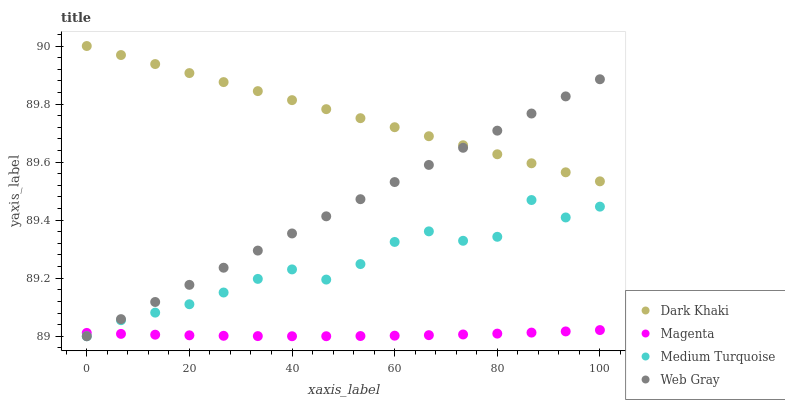Does Magenta have the minimum area under the curve?
Answer yes or no. Yes. Does Dark Khaki have the maximum area under the curve?
Answer yes or no. Yes. Does Web Gray have the minimum area under the curve?
Answer yes or no. No. Does Web Gray have the maximum area under the curve?
Answer yes or no. No. Is Web Gray the smoothest?
Answer yes or no. Yes. Is Medium Turquoise the roughest?
Answer yes or no. Yes. Is Magenta the smoothest?
Answer yes or no. No. Is Magenta the roughest?
Answer yes or no. No. Does Web Gray have the lowest value?
Answer yes or no. Yes. Does Magenta have the lowest value?
Answer yes or no. No. Does Dark Khaki have the highest value?
Answer yes or no. Yes. Does Web Gray have the highest value?
Answer yes or no. No. Is Medium Turquoise less than Dark Khaki?
Answer yes or no. Yes. Is Dark Khaki greater than Medium Turquoise?
Answer yes or no. Yes. Does Medium Turquoise intersect Magenta?
Answer yes or no. Yes. Is Medium Turquoise less than Magenta?
Answer yes or no. No. Is Medium Turquoise greater than Magenta?
Answer yes or no. No. Does Medium Turquoise intersect Dark Khaki?
Answer yes or no. No. 